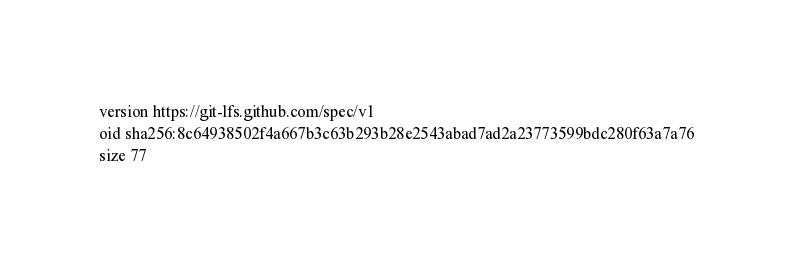<code> <loc_0><loc_0><loc_500><loc_500><_YAML_>version https://git-lfs.github.com/spec/v1
oid sha256:8c64938502f4a667b3c63b293b28e2543abad7ad2a23773599bdc280f63a7a76
size 77
</code> 